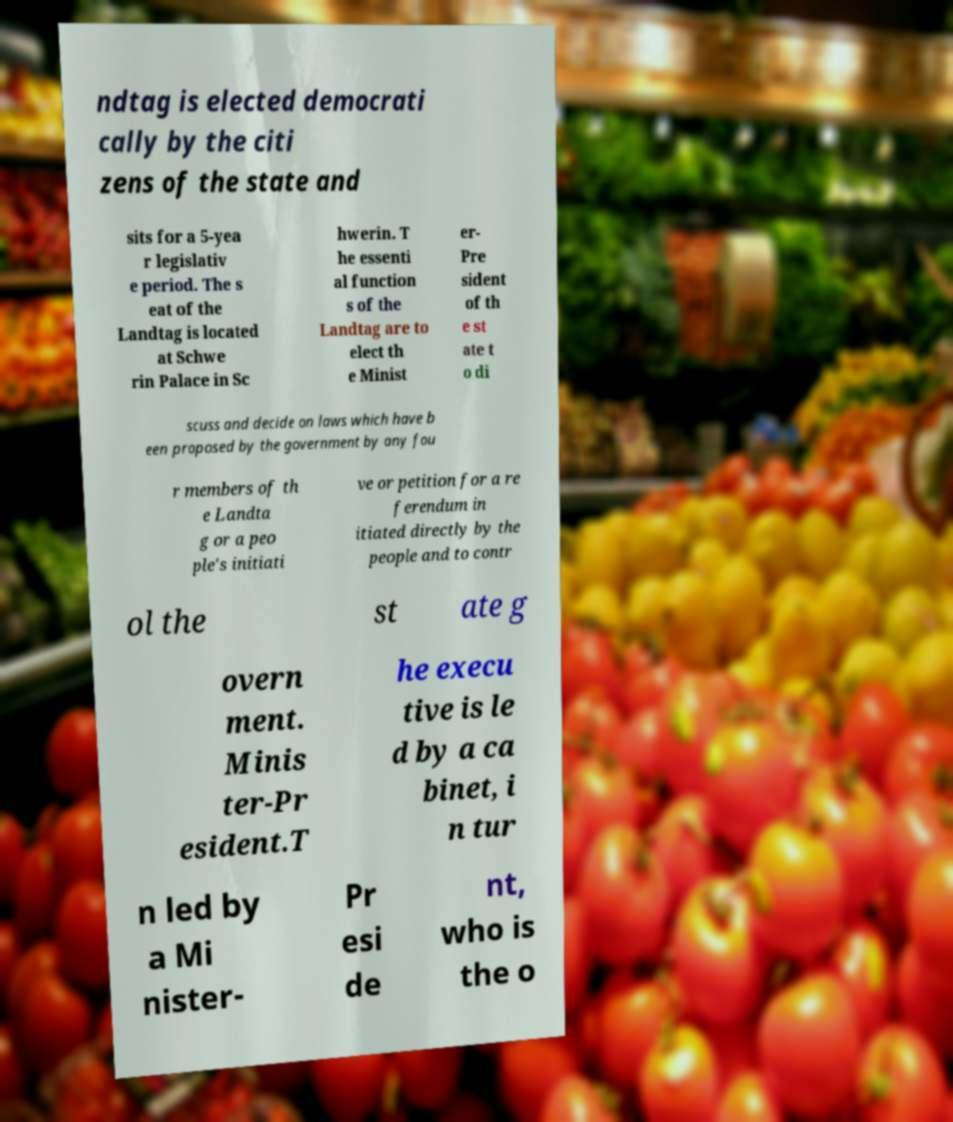I need the written content from this picture converted into text. Can you do that? ndtag is elected democrati cally by the citi zens of the state and sits for a 5-yea r legislativ e period. The s eat of the Landtag is located at Schwe rin Palace in Sc hwerin. T he essenti al function s of the Landtag are to elect th e Minist er- Pre sident of th e st ate t o di scuss and decide on laws which have b een proposed by the government by any fou r members of th e Landta g or a peo ple's initiati ve or petition for a re ferendum in itiated directly by the people and to contr ol the st ate g overn ment. Minis ter-Pr esident.T he execu tive is le d by a ca binet, i n tur n led by a Mi nister- Pr esi de nt, who is the o 